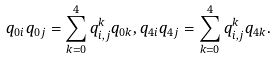Convert formula to latex. <formula><loc_0><loc_0><loc_500><loc_500>q _ { 0 i } q _ { 0 j } = \sum _ { k = 0 } ^ { 4 } q _ { i , j } ^ { k } q _ { 0 k } , q _ { 4 i } q _ { 4 j } = \sum _ { k = 0 } ^ { 4 } q _ { i , j } ^ { k } q _ { 4 k } .</formula> 